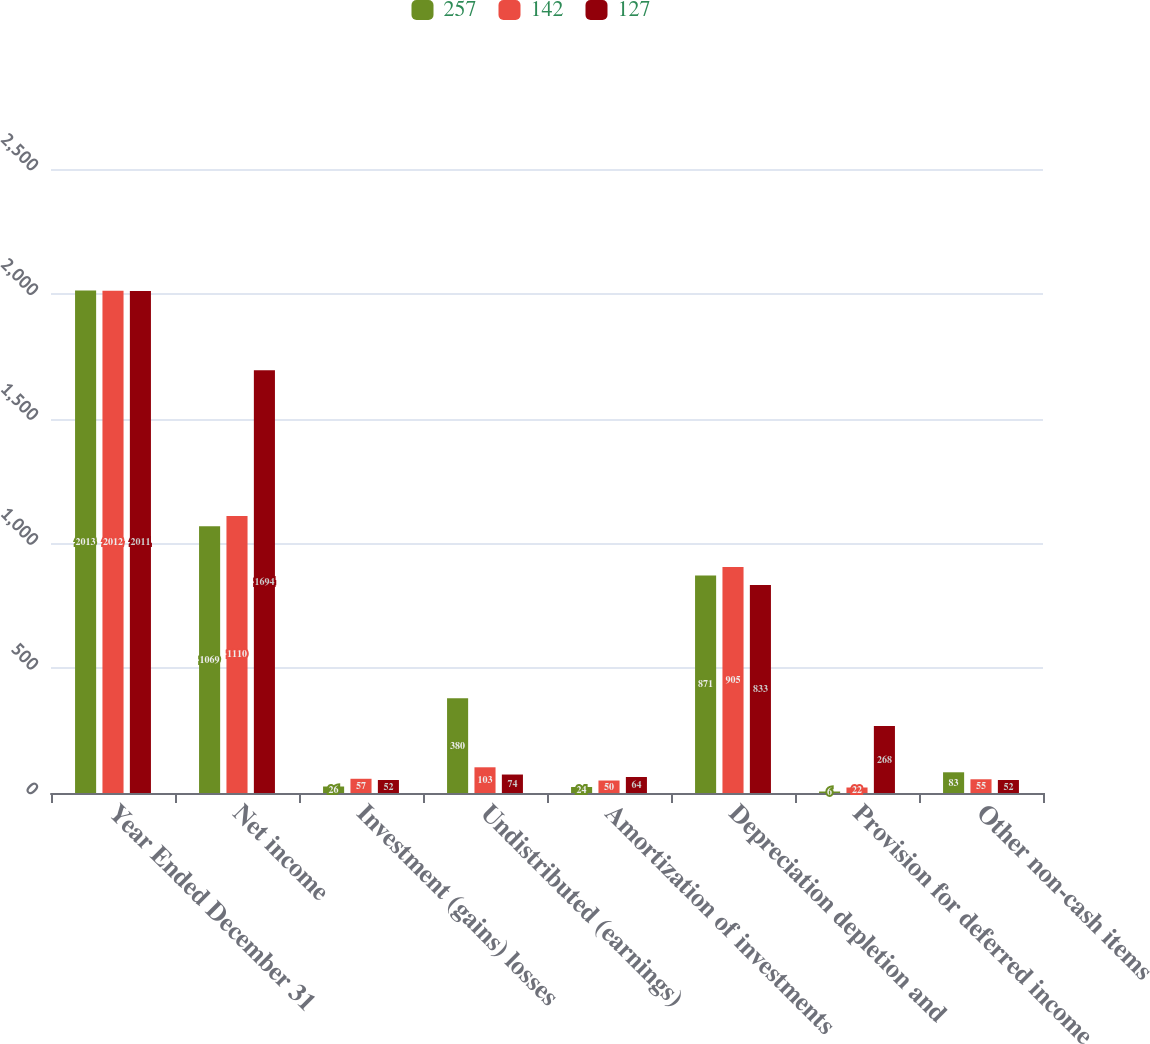Convert chart to OTSL. <chart><loc_0><loc_0><loc_500><loc_500><stacked_bar_chart><ecel><fcel>Year Ended December 31<fcel>Net income<fcel>Investment (gains) losses<fcel>Undistributed (earnings)<fcel>Amortization of investments<fcel>Depreciation depletion and<fcel>Provision for deferred income<fcel>Other non-cash items<nl><fcel>257<fcel>2013<fcel>1069<fcel>26<fcel>380<fcel>24<fcel>871<fcel>6<fcel>83<nl><fcel>142<fcel>2012<fcel>1110<fcel>57<fcel>103<fcel>50<fcel>905<fcel>22<fcel>55<nl><fcel>127<fcel>2011<fcel>1694<fcel>52<fcel>74<fcel>64<fcel>833<fcel>268<fcel>52<nl></chart> 